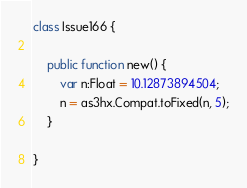Convert code to text. <code><loc_0><loc_0><loc_500><loc_500><_Haxe_>class Issue166 {

	public function new() {
		var n:Float = 10.12873894504;
		n = as3hx.Compat.toFixed(n, 5);
	}

}</code> 